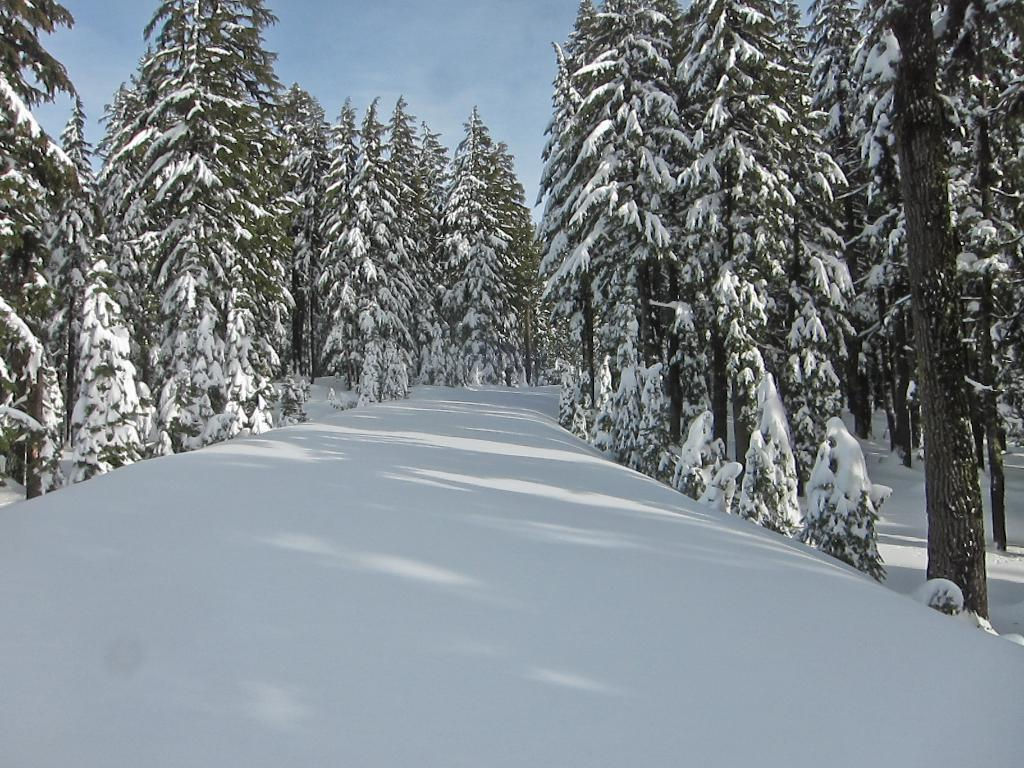Where was the picture taken? The picture was taken outside. What is the predominant weather condition in the image? There is a lot of snow in the image. What type of natural elements can be seen in the center of the image? There are trees and plants in the center of the image. What can be seen in the background of the image? The sky is visible in the background of the image. What type of worm is used as bait for fishing in the image? There is no worm or fishing activity present in the image; it features a snowy outdoor scene with trees and plants. 